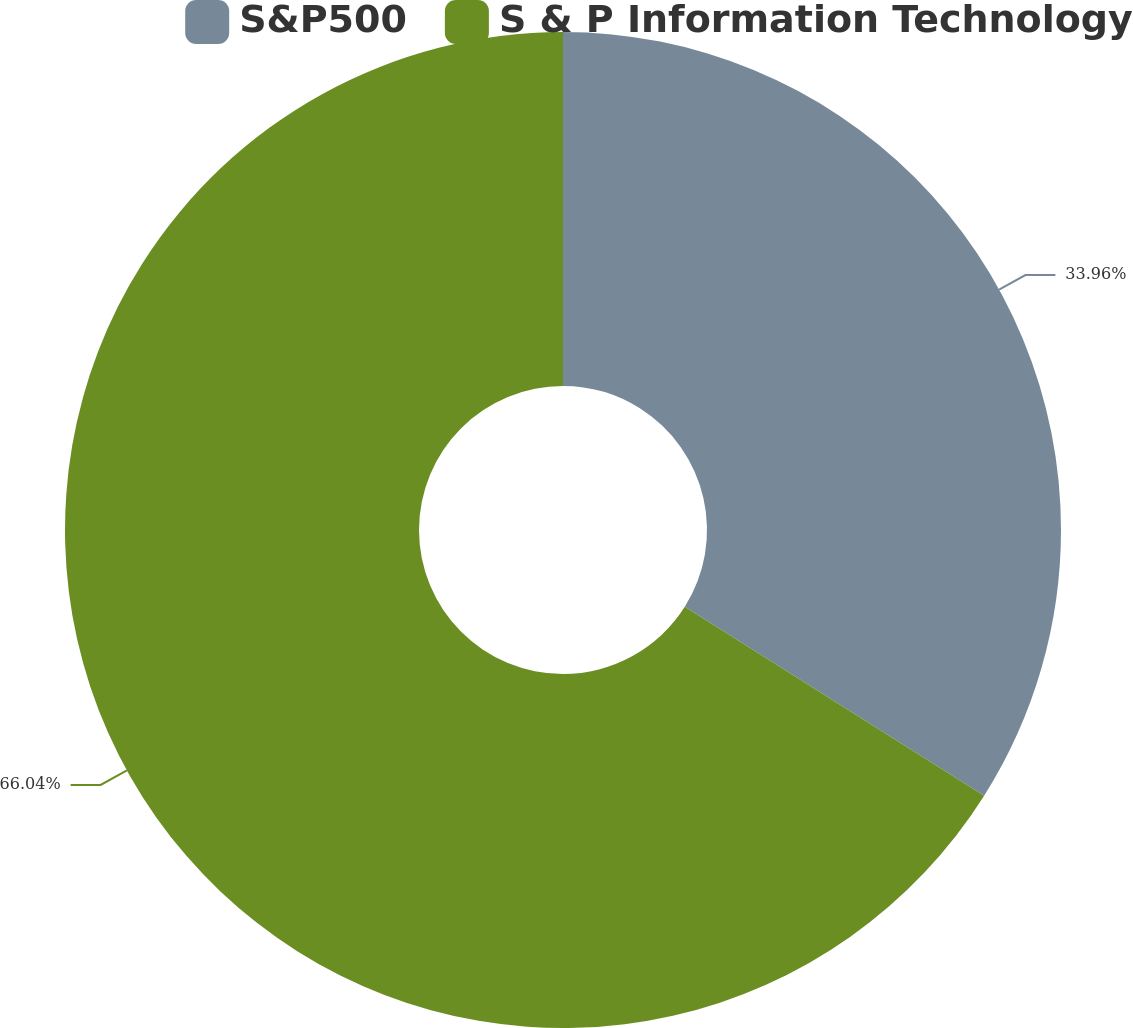<chart> <loc_0><loc_0><loc_500><loc_500><pie_chart><fcel>S&P500<fcel>S & P Information Technology<nl><fcel>33.96%<fcel>66.04%<nl></chart> 